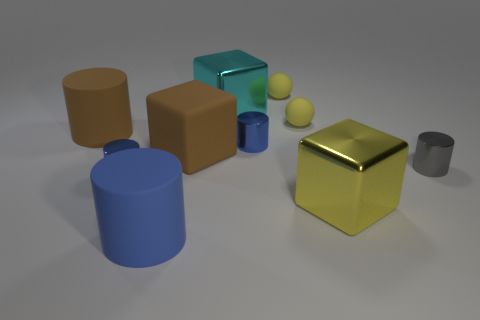Subtract all blue cylinders. How many were subtracted if there are1blue cylinders left? 2 Subtract all yellow metal blocks. How many blocks are left? 2 Subtract all yellow cubes. How many cubes are left? 2 Subtract all green cubes. How many blue cylinders are left? 3 Subtract all spheres. How many objects are left? 8 Add 8 yellow shiny objects. How many yellow shiny objects are left? 9 Add 2 tiny blue objects. How many tiny blue objects exist? 4 Subtract 1 yellow cubes. How many objects are left? 9 Subtract 2 spheres. How many spheres are left? 0 Subtract all blue blocks. Subtract all red cylinders. How many blocks are left? 3 